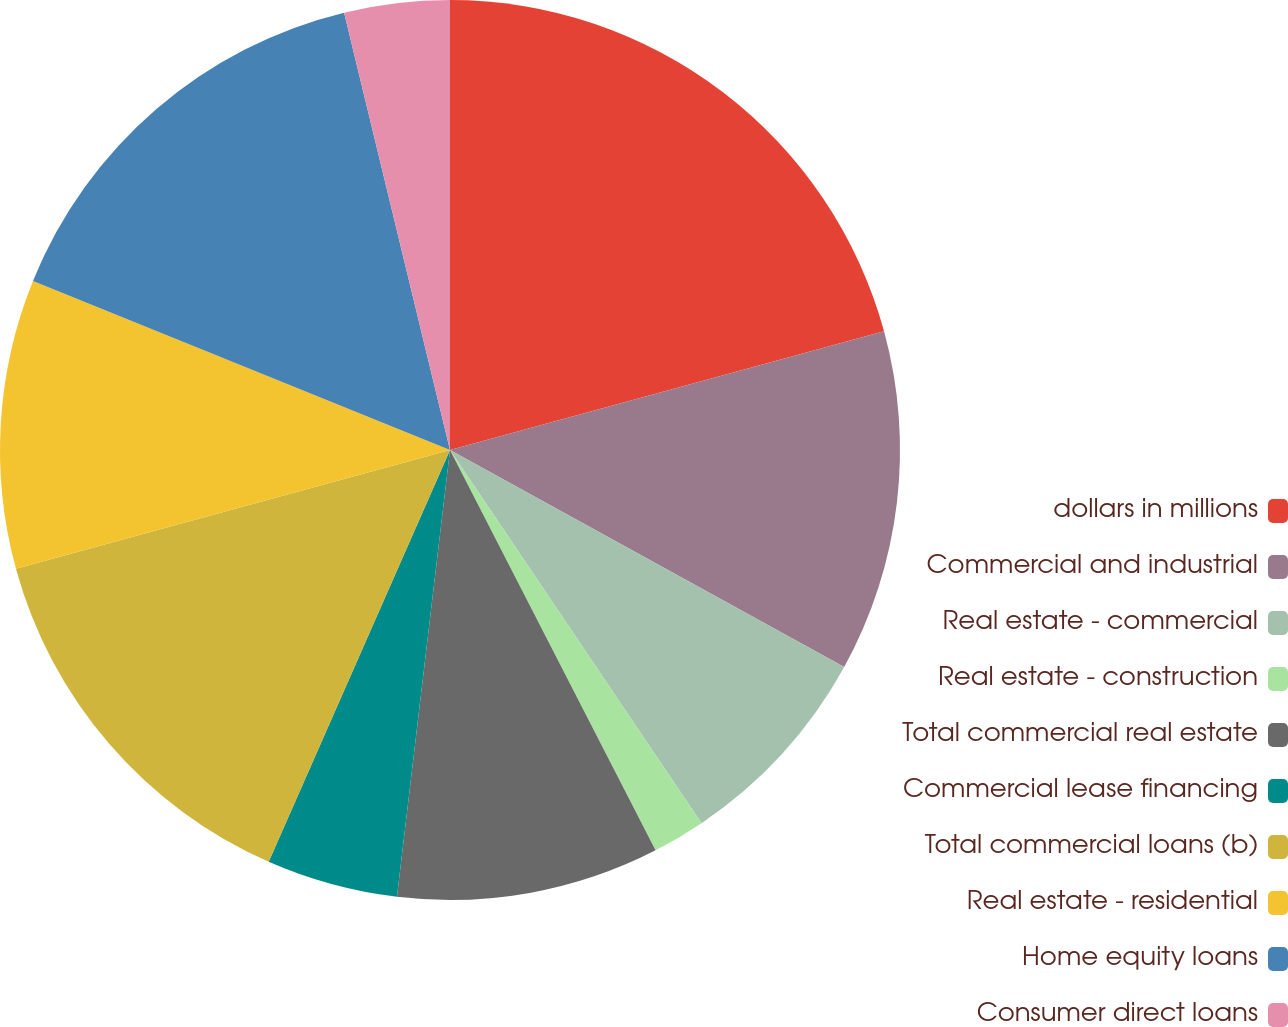Convert chart. <chart><loc_0><loc_0><loc_500><loc_500><pie_chart><fcel>dollars in millions<fcel>Commercial and industrial<fcel>Real estate - commercial<fcel>Real estate - construction<fcel>Total commercial real estate<fcel>Commercial lease financing<fcel>Total commercial loans (b)<fcel>Real estate - residential<fcel>Home equity loans<fcel>Consumer direct loans<nl><fcel>20.75%<fcel>12.26%<fcel>7.55%<fcel>1.89%<fcel>9.43%<fcel>4.72%<fcel>14.15%<fcel>10.38%<fcel>15.09%<fcel>3.78%<nl></chart> 